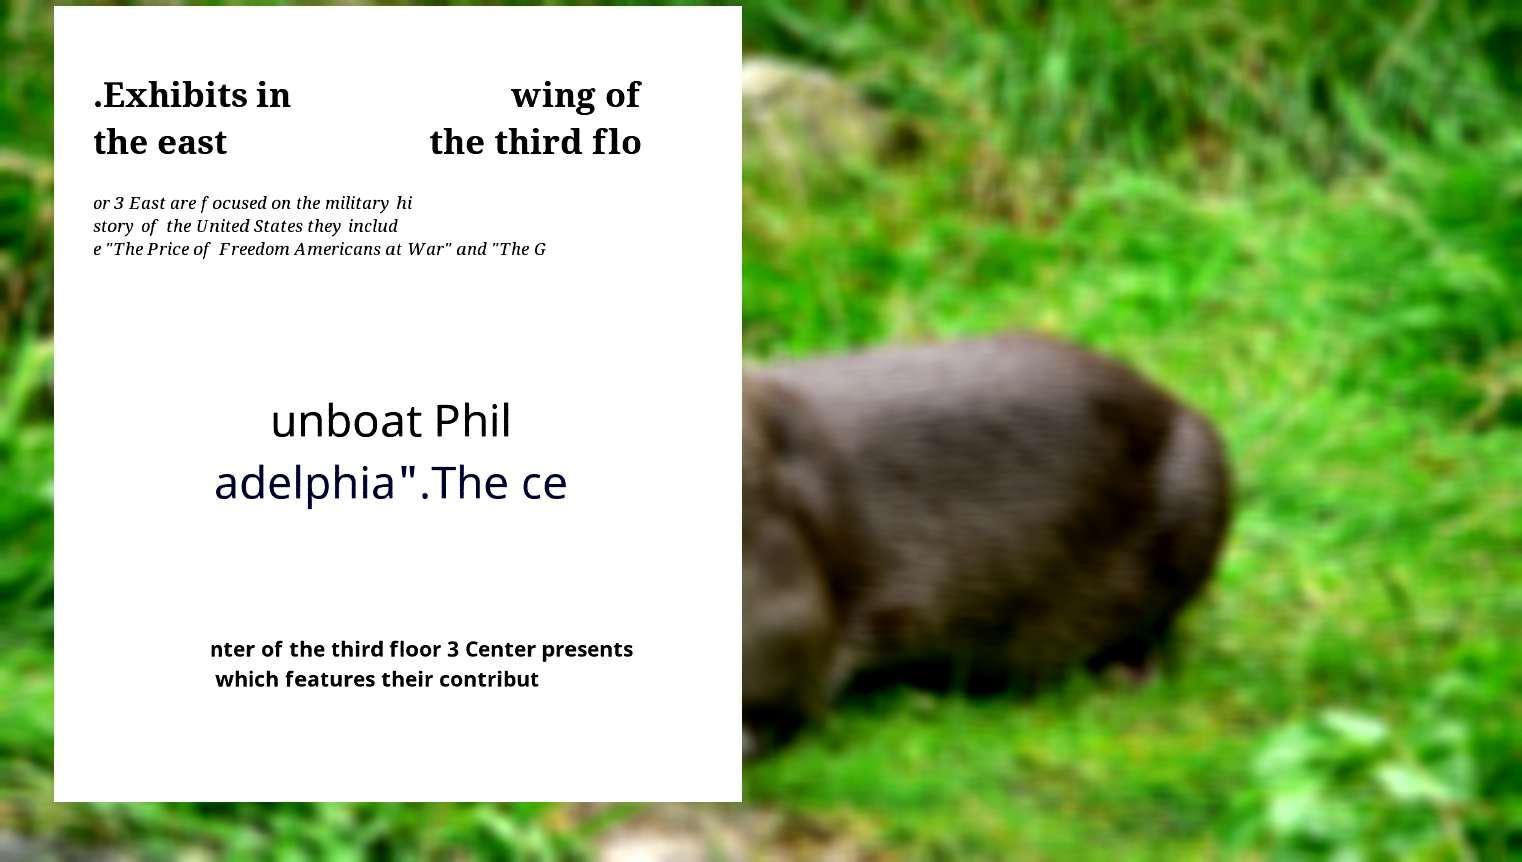Could you assist in decoding the text presented in this image and type it out clearly? .Exhibits in the east wing of the third flo or 3 East are focused on the military hi story of the United States they includ e "The Price of Freedom Americans at War" and "The G unboat Phil adelphia".The ce nter of the third floor 3 Center presents which features their contribut 